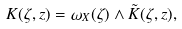Convert formula to latex. <formula><loc_0><loc_0><loc_500><loc_500>K ( \zeta , z ) = \omega _ { X } ( \zeta ) \wedge \tilde { K } ( \zeta , z ) ,</formula> 